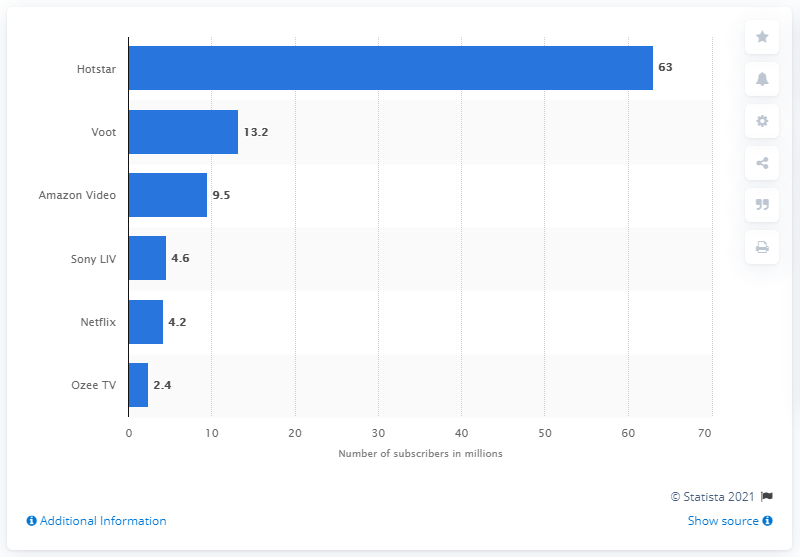Specify some key components in this picture. As of January 2017, Netflix had approximately 4.2 million subscribers in India. 